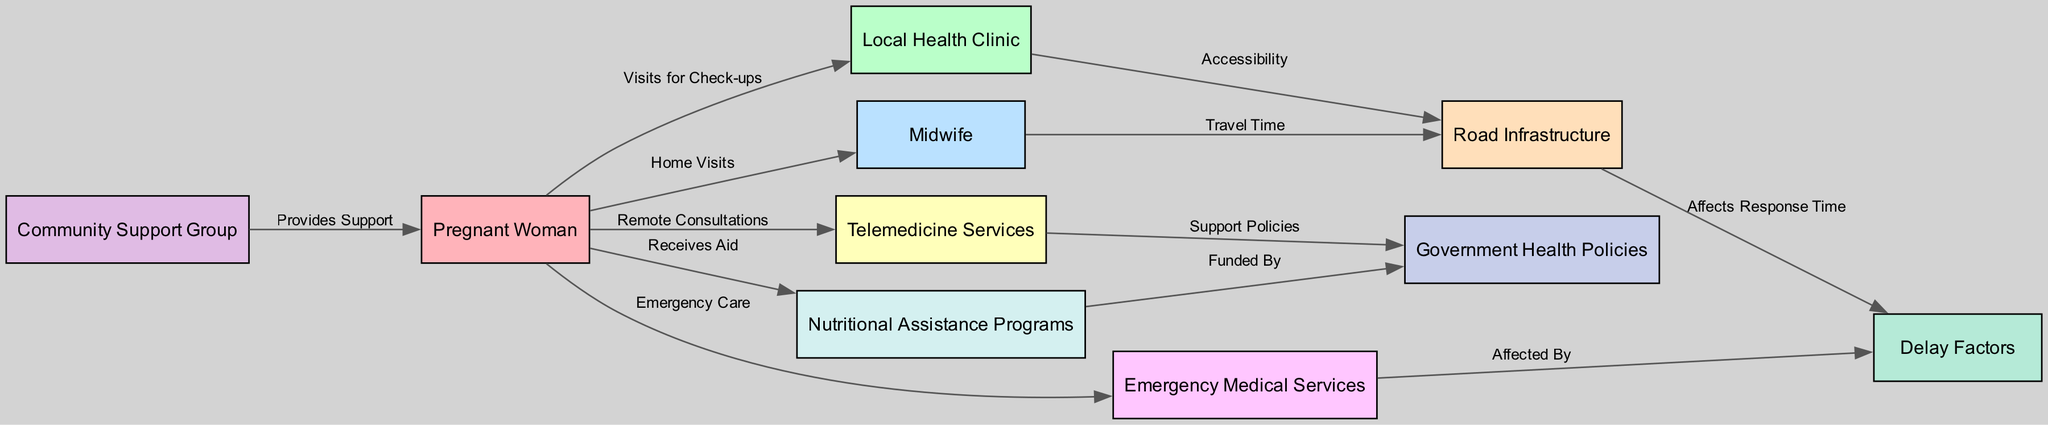what is the total number of nodes in the diagram? The diagram contains 10 distinct nodes representing various elements related to health services for pregnant women. This is counted directly from the provided node list.
Answer: 10 what is the main service the pregnant woman accesses from the local health clinic? The pregnant woman visits the local health clinic primarily for check-ups, as indicated by the edge labeled "Visits for Check-ups" connecting both nodes.
Answer: Check-ups which node is linked to both telemedicine services and government health policies? The telemedicine services node has an edge leading to government health policies, demonstrating a connection between remote consultations and the support policies in place.
Answer: Telemedicine Services what relationship exists between the local health clinic and road infrastructure? The local health clinic is linked to road infrastructure by the edge labeled "Accessibility," indicating that the condition and availability of roads affect how accessible the clinic is for pregnant women.
Answer: Accessibility how does nutritional assistance relate to government health policies? The nutritional assistance programs are directly impacted by government health policies, as shown by the edge labeled "Funded By," linking the nutritional programs to the government policies overseeing funding.
Answer: Funded By which two nodes are connected by the label “Provides Support”? The community support group and the pregnant woman are connected, demonstrating that the community support group plays a role in providing help to the pregnant woman.
Answer: Community Support Group how are delay factors connected to emergency medical services? Delay factors affect the response time of emergency medical services, which is represented by the edge labeled “Affected By,” indicating that various delay factors can slow down the speed of emergency assistance.
Answer: Affected By what type of assistance does the pregnant woman receive from nutritional assistance programs? The pregnant woman receives aid from nutritional assistance programs, as represented by the edge labeled “Receives Aid” connecting the two nodes.
Answer: Receives Aid what aspect of transportation is linked to the midwife? The midwife's travel time is directly connected to road infrastructure, indicating that how quickly they can reach the pregnant woman depends on the roads available.
Answer: Travel Time which node describes the potential issues affecting response times? The delay factors node indicates various issues that can affect how quickly health services respond to the needs of pregnant women in remote areas.
Answer: Delay Factors 